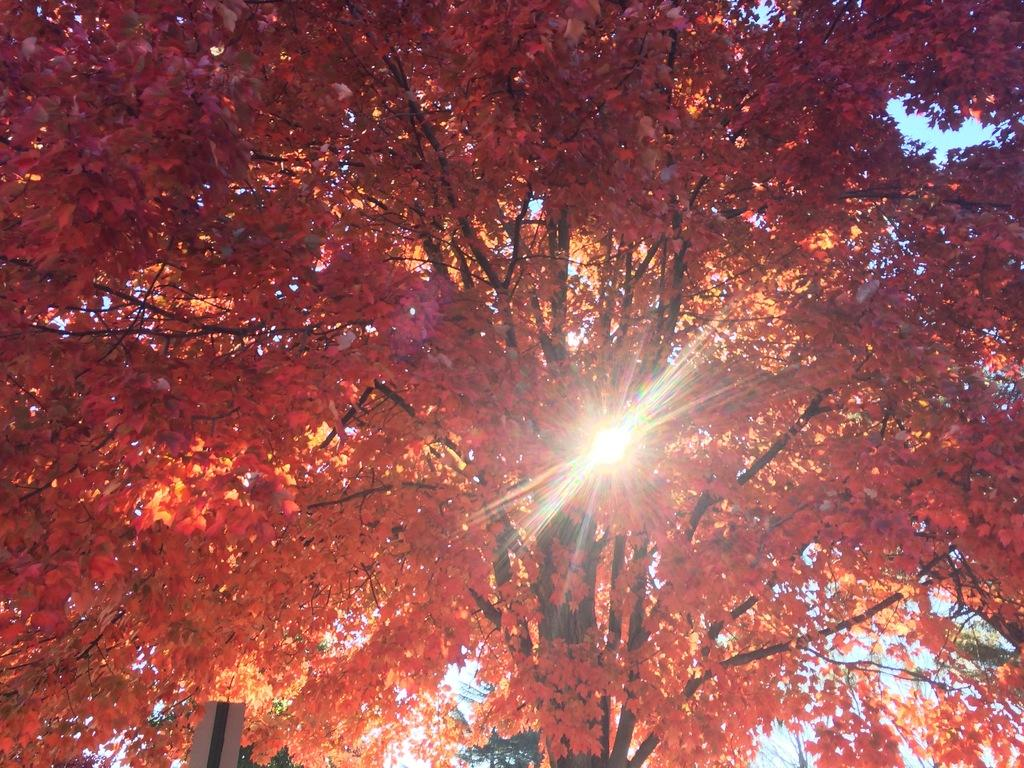What is present in the image? There is a tree in the image. What is unique about the tree's appearance? The tree has orange leaves. Can you describe the lighting in the image? Sunlight is visible through the leaves of the tree. What type of committee can be seen meeting under the tree in the image? There is no committee present in the image; it only features a tree with orange leaves and sunlight shining through its leaves. 